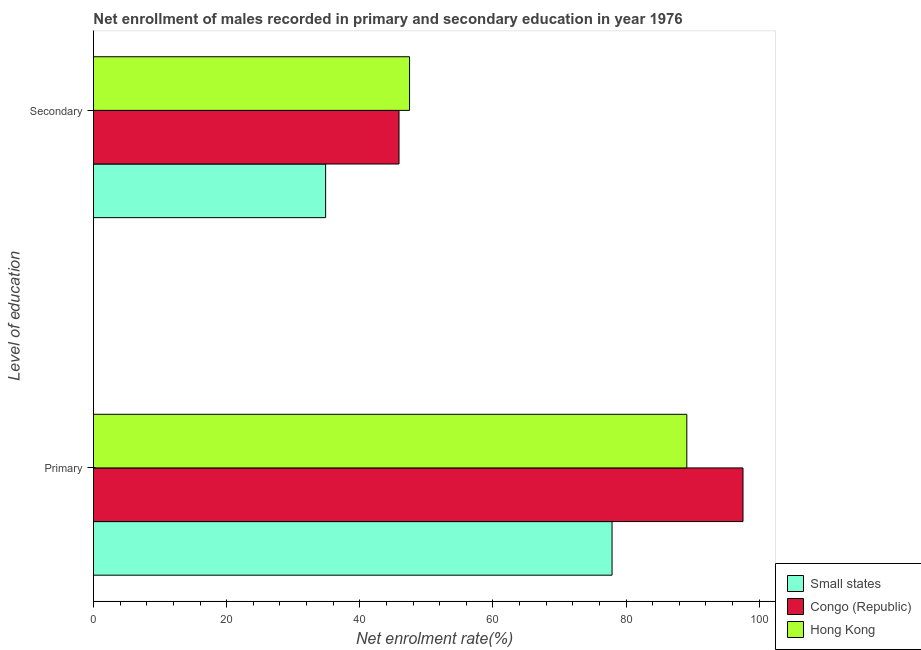Are the number of bars on each tick of the Y-axis equal?
Offer a terse response. Yes. How many bars are there on the 2nd tick from the bottom?
Your answer should be compact. 3. What is the label of the 2nd group of bars from the top?
Keep it short and to the point. Primary. What is the enrollment rate in primary education in Congo (Republic)?
Offer a terse response. 97.56. Across all countries, what is the maximum enrollment rate in primary education?
Offer a terse response. 97.56. Across all countries, what is the minimum enrollment rate in primary education?
Provide a short and direct response. 77.89. In which country was the enrollment rate in secondary education maximum?
Provide a succinct answer. Hong Kong. In which country was the enrollment rate in secondary education minimum?
Your answer should be compact. Small states. What is the total enrollment rate in primary education in the graph?
Offer a very short reply. 264.57. What is the difference between the enrollment rate in secondary education in Congo (Republic) and that in Small states?
Give a very brief answer. 11.02. What is the difference between the enrollment rate in primary education in Small states and the enrollment rate in secondary education in Hong Kong?
Keep it short and to the point. 30.41. What is the average enrollment rate in secondary education per country?
Provide a succinct answer. 42.75. What is the difference between the enrollment rate in primary education and enrollment rate in secondary education in Small states?
Offer a terse response. 43.02. What is the ratio of the enrollment rate in secondary education in Small states to that in Congo (Republic)?
Provide a short and direct response. 0.76. Is the enrollment rate in primary education in Congo (Republic) less than that in Hong Kong?
Ensure brevity in your answer.  No. What does the 1st bar from the top in Primary represents?
Keep it short and to the point. Hong Kong. What does the 2nd bar from the bottom in Primary represents?
Offer a very short reply. Congo (Republic). How many bars are there?
Your answer should be very brief. 6. How many countries are there in the graph?
Make the answer very short. 3. What is the difference between two consecutive major ticks on the X-axis?
Your answer should be very brief. 20. Does the graph contain any zero values?
Keep it short and to the point. No. Does the graph contain grids?
Your answer should be very brief. No. What is the title of the graph?
Make the answer very short. Net enrollment of males recorded in primary and secondary education in year 1976. What is the label or title of the X-axis?
Ensure brevity in your answer.  Net enrolment rate(%). What is the label or title of the Y-axis?
Ensure brevity in your answer.  Level of education. What is the Net enrolment rate(%) in Small states in Primary?
Provide a short and direct response. 77.89. What is the Net enrolment rate(%) of Congo (Republic) in Primary?
Offer a terse response. 97.56. What is the Net enrolment rate(%) in Hong Kong in Primary?
Keep it short and to the point. 89.12. What is the Net enrolment rate(%) of Small states in Secondary?
Offer a terse response. 34.87. What is the Net enrolment rate(%) of Congo (Republic) in Secondary?
Your answer should be very brief. 45.89. What is the Net enrolment rate(%) in Hong Kong in Secondary?
Provide a short and direct response. 47.48. Across all Level of education, what is the maximum Net enrolment rate(%) in Small states?
Offer a very short reply. 77.89. Across all Level of education, what is the maximum Net enrolment rate(%) in Congo (Republic)?
Your answer should be compact. 97.56. Across all Level of education, what is the maximum Net enrolment rate(%) of Hong Kong?
Make the answer very short. 89.12. Across all Level of education, what is the minimum Net enrolment rate(%) in Small states?
Offer a terse response. 34.87. Across all Level of education, what is the minimum Net enrolment rate(%) of Congo (Republic)?
Keep it short and to the point. 45.89. Across all Level of education, what is the minimum Net enrolment rate(%) in Hong Kong?
Your answer should be very brief. 47.48. What is the total Net enrolment rate(%) in Small states in the graph?
Your response must be concise. 112.76. What is the total Net enrolment rate(%) in Congo (Republic) in the graph?
Keep it short and to the point. 143.45. What is the total Net enrolment rate(%) in Hong Kong in the graph?
Offer a terse response. 136.6. What is the difference between the Net enrolment rate(%) of Small states in Primary and that in Secondary?
Provide a succinct answer. 43.02. What is the difference between the Net enrolment rate(%) in Congo (Republic) in Primary and that in Secondary?
Make the answer very short. 51.67. What is the difference between the Net enrolment rate(%) in Hong Kong in Primary and that in Secondary?
Make the answer very short. 41.64. What is the difference between the Net enrolment rate(%) in Small states in Primary and the Net enrolment rate(%) in Congo (Republic) in Secondary?
Provide a succinct answer. 32. What is the difference between the Net enrolment rate(%) in Small states in Primary and the Net enrolment rate(%) in Hong Kong in Secondary?
Provide a short and direct response. 30.41. What is the difference between the Net enrolment rate(%) in Congo (Republic) in Primary and the Net enrolment rate(%) in Hong Kong in Secondary?
Give a very brief answer. 50.08. What is the average Net enrolment rate(%) of Small states per Level of education?
Provide a short and direct response. 56.38. What is the average Net enrolment rate(%) in Congo (Republic) per Level of education?
Offer a terse response. 71.73. What is the average Net enrolment rate(%) of Hong Kong per Level of education?
Provide a succinct answer. 68.3. What is the difference between the Net enrolment rate(%) of Small states and Net enrolment rate(%) of Congo (Republic) in Primary?
Keep it short and to the point. -19.67. What is the difference between the Net enrolment rate(%) in Small states and Net enrolment rate(%) in Hong Kong in Primary?
Offer a very short reply. -11.23. What is the difference between the Net enrolment rate(%) in Congo (Republic) and Net enrolment rate(%) in Hong Kong in Primary?
Ensure brevity in your answer.  8.44. What is the difference between the Net enrolment rate(%) of Small states and Net enrolment rate(%) of Congo (Republic) in Secondary?
Your answer should be compact. -11.02. What is the difference between the Net enrolment rate(%) in Small states and Net enrolment rate(%) in Hong Kong in Secondary?
Make the answer very short. -12.61. What is the difference between the Net enrolment rate(%) of Congo (Republic) and Net enrolment rate(%) of Hong Kong in Secondary?
Give a very brief answer. -1.58. What is the ratio of the Net enrolment rate(%) of Small states in Primary to that in Secondary?
Your answer should be compact. 2.23. What is the ratio of the Net enrolment rate(%) in Congo (Republic) in Primary to that in Secondary?
Your response must be concise. 2.13. What is the ratio of the Net enrolment rate(%) in Hong Kong in Primary to that in Secondary?
Give a very brief answer. 1.88. What is the difference between the highest and the second highest Net enrolment rate(%) of Small states?
Provide a succinct answer. 43.02. What is the difference between the highest and the second highest Net enrolment rate(%) of Congo (Republic)?
Offer a terse response. 51.67. What is the difference between the highest and the second highest Net enrolment rate(%) in Hong Kong?
Give a very brief answer. 41.64. What is the difference between the highest and the lowest Net enrolment rate(%) in Small states?
Your response must be concise. 43.02. What is the difference between the highest and the lowest Net enrolment rate(%) of Congo (Republic)?
Provide a short and direct response. 51.67. What is the difference between the highest and the lowest Net enrolment rate(%) in Hong Kong?
Ensure brevity in your answer.  41.64. 